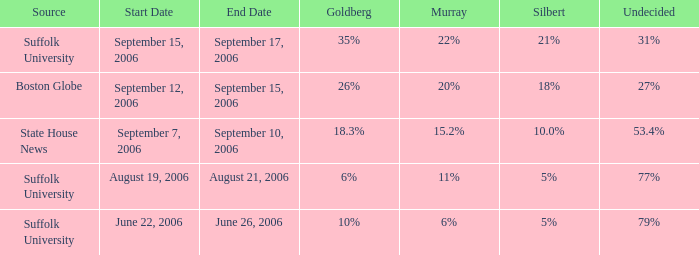On which date is the poll showing silbert at 1 September 7–10, 2006. 